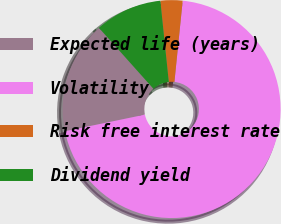<chart> <loc_0><loc_0><loc_500><loc_500><pie_chart><fcel>Expected life (years)<fcel>Volatility<fcel>Risk free interest rate<fcel>Dividend yield<nl><fcel>16.64%<fcel>70.13%<fcel>3.27%<fcel>9.96%<nl></chart> 